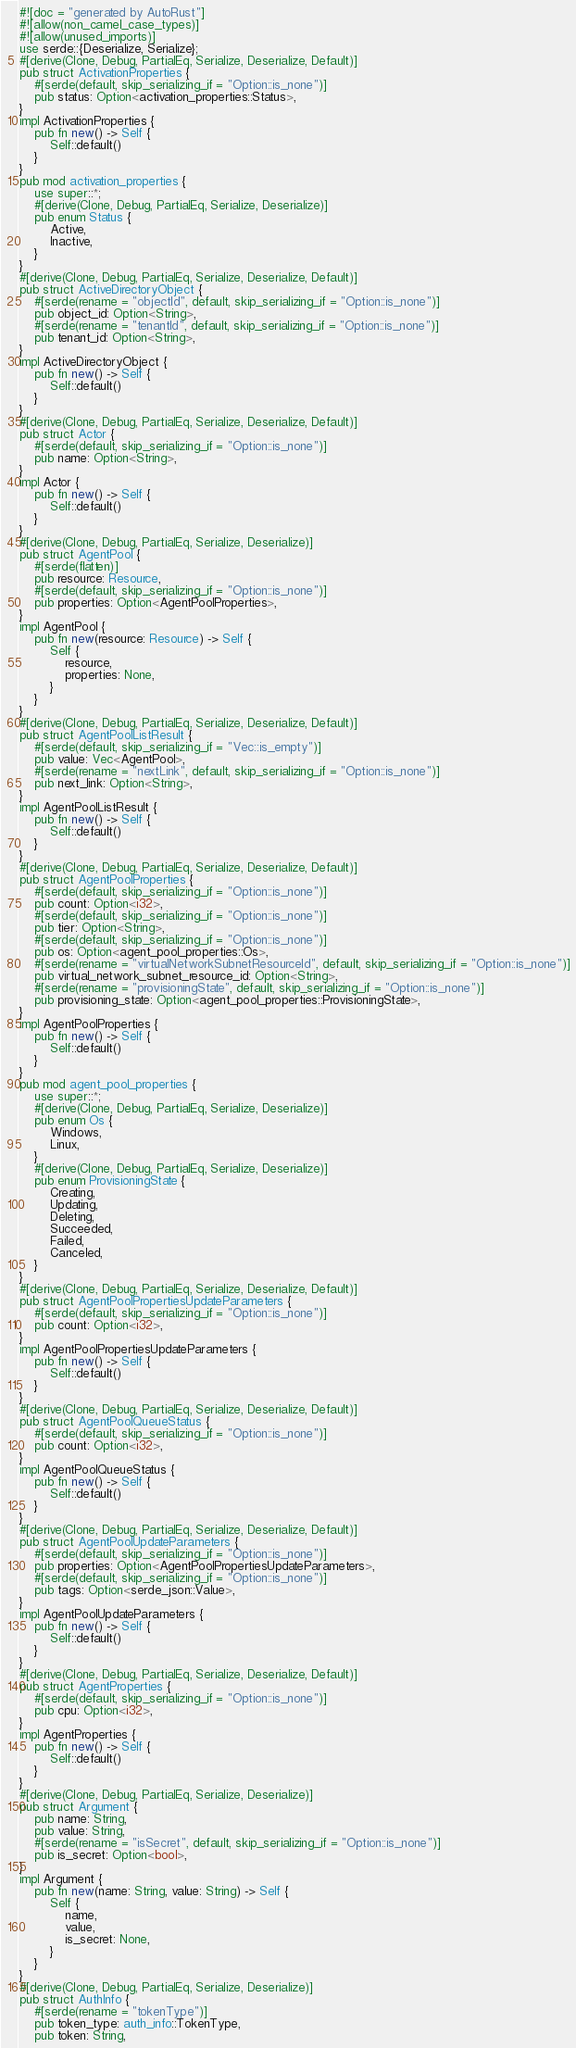<code> <loc_0><loc_0><loc_500><loc_500><_Rust_>#![doc = "generated by AutoRust"]
#![allow(non_camel_case_types)]
#![allow(unused_imports)]
use serde::{Deserialize, Serialize};
#[derive(Clone, Debug, PartialEq, Serialize, Deserialize, Default)]
pub struct ActivationProperties {
    #[serde(default, skip_serializing_if = "Option::is_none")]
    pub status: Option<activation_properties::Status>,
}
impl ActivationProperties {
    pub fn new() -> Self {
        Self::default()
    }
}
pub mod activation_properties {
    use super::*;
    #[derive(Clone, Debug, PartialEq, Serialize, Deserialize)]
    pub enum Status {
        Active,
        Inactive,
    }
}
#[derive(Clone, Debug, PartialEq, Serialize, Deserialize, Default)]
pub struct ActiveDirectoryObject {
    #[serde(rename = "objectId", default, skip_serializing_if = "Option::is_none")]
    pub object_id: Option<String>,
    #[serde(rename = "tenantId", default, skip_serializing_if = "Option::is_none")]
    pub tenant_id: Option<String>,
}
impl ActiveDirectoryObject {
    pub fn new() -> Self {
        Self::default()
    }
}
#[derive(Clone, Debug, PartialEq, Serialize, Deserialize, Default)]
pub struct Actor {
    #[serde(default, skip_serializing_if = "Option::is_none")]
    pub name: Option<String>,
}
impl Actor {
    pub fn new() -> Self {
        Self::default()
    }
}
#[derive(Clone, Debug, PartialEq, Serialize, Deserialize)]
pub struct AgentPool {
    #[serde(flatten)]
    pub resource: Resource,
    #[serde(default, skip_serializing_if = "Option::is_none")]
    pub properties: Option<AgentPoolProperties>,
}
impl AgentPool {
    pub fn new(resource: Resource) -> Self {
        Self {
            resource,
            properties: None,
        }
    }
}
#[derive(Clone, Debug, PartialEq, Serialize, Deserialize, Default)]
pub struct AgentPoolListResult {
    #[serde(default, skip_serializing_if = "Vec::is_empty")]
    pub value: Vec<AgentPool>,
    #[serde(rename = "nextLink", default, skip_serializing_if = "Option::is_none")]
    pub next_link: Option<String>,
}
impl AgentPoolListResult {
    pub fn new() -> Self {
        Self::default()
    }
}
#[derive(Clone, Debug, PartialEq, Serialize, Deserialize, Default)]
pub struct AgentPoolProperties {
    #[serde(default, skip_serializing_if = "Option::is_none")]
    pub count: Option<i32>,
    #[serde(default, skip_serializing_if = "Option::is_none")]
    pub tier: Option<String>,
    #[serde(default, skip_serializing_if = "Option::is_none")]
    pub os: Option<agent_pool_properties::Os>,
    #[serde(rename = "virtualNetworkSubnetResourceId", default, skip_serializing_if = "Option::is_none")]
    pub virtual_network_subnet_resource_id: Option<String>,
    #[serde(rename = "provisioningState", default, skip_serializing_if = "Option::is_none")]
    pub provisioning_state: Option<agent_pool_properties::ProvisioningState>,
}
impl AgentPoolProperties {
    pub fn new() -> Self {
        Self::default()
    }
}
pub mod agent_pool_properties {
    use super::*;
    #[derive(Clone, Debug, PartialEq, Serialize, Deserialize)]
    pub enum Os {
        Windows,
        Linux,
    }
    #[derive(Clone, Debug, PartialEq, Serialize, Deserialize)]
    pub enum ProvisioningState {
        Creating,
        Updating,
        Deleting,
        Succeeded,
        Failed,
        Canceled,
    }
}
#[derive(Clone, Debug, PartialEq, Serialize, Deserialize, Default)]
pub struct AgentPoolPropertiesUpdateParameters {
    #[serde(default, skip_serializing_if = "Option::is_none")]
    pub count: Option<i32>,
}
impl AgentPoolPropertiesUpdateParameters {
    pub fn new() -> Self {
        Self::default()
    }
}
#[derive(Clone, Debug, PartialEq, Serialize, Deserialize, Default)]
pub struct AgentPoolQueueStatus {
    #[serde(default, skip_serializing_if = "Option::is_none")]
    pub count: Option<i32>,
}
impl AgentPoolQueueStatus {
    pub fn new() -> Self {
        Self::default()
    }
}
#[derive(Clone, Debug, PartialEq, Serialize, Deserialize, Default)]
pub struct AgentPoolUpdateParameters {
    #[serde(default, skip_serializing_if = "Option::is_none")]
    pub properties: Option<AgentPoolPropertiesUpdateParameters>,
    #[serde(default, skip_serializing_if = "Option::is_none")]
    pub tags: Option<serde_json::Value>,
}
impl AgentPoolUpdateParameters {
    pub fn new() -> Self {
        Self::default()
    }
}
#[derive(Clone, Debug, PartialEq, Serialize, Deserialize, Default)]
pub struct AgentProperties {
    #[serde(default, skip_serializing_if = "Option::is_none")]
    pub cpu: Option<i32>,
}
impl AgentProperties {
    pub fn new() -> Self {
        Self::default()
    }
}
#[derive(Clone, Debug, PartialEq, Serialize, Deserialize)]
pub struct Argument {
    pub name: String,
    pub value: String,
    #[serde(rename = "isSecret", default, skip_serializing_if = "Option::is_none")]
    pub is_secret: Option<bool>,
}
impl Argument {
    pub fn new(name: String, value: String) -> Self {
        Self {
            name,
            value,
            is_secret: None,
        }
    }
}
#[derive(Clone, Debug, PartialEq, Serialize, Deserialize)]
pub struct AuthInfo {
    #[serde(rename = "tokenType")]
    pub token_type: auth_info::TokenType,
    pub token: String,</code> 